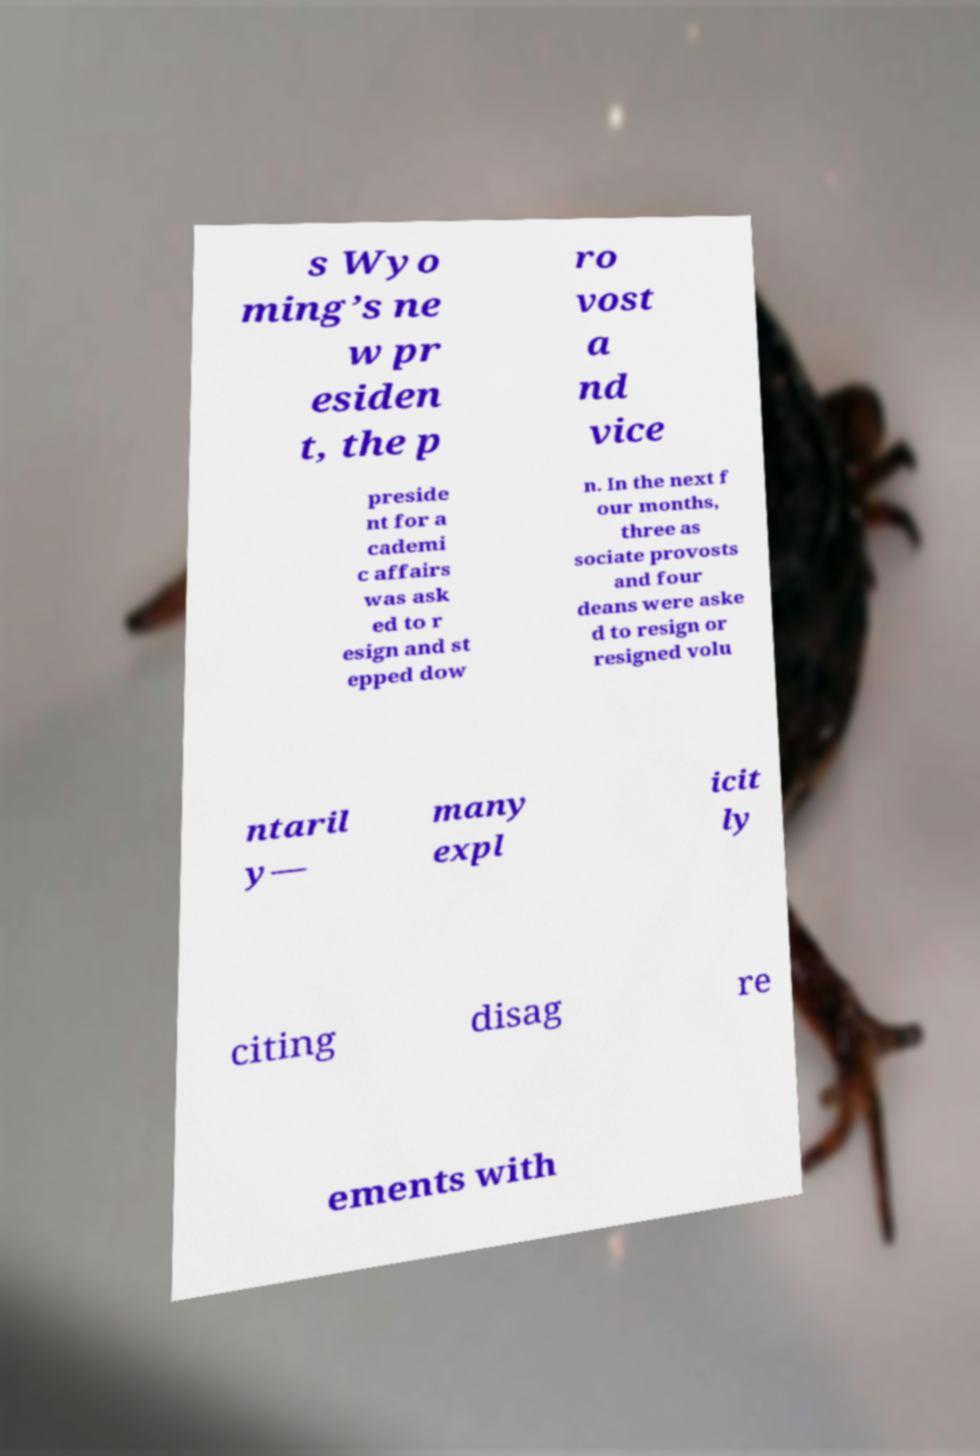Could you assist in decoding the text presented in this image and type it out clearly? s Wyo ming’s ne w pr esiden t, the p ro vost a nd vice preside nt for a cademi c affairs was ask ed to r esign and st epped dow n. In the next f our months, three as sociate provosts and four deans were aske d to resign or resigned volu ntaril y— many expl icit ly citing disag re ements with 